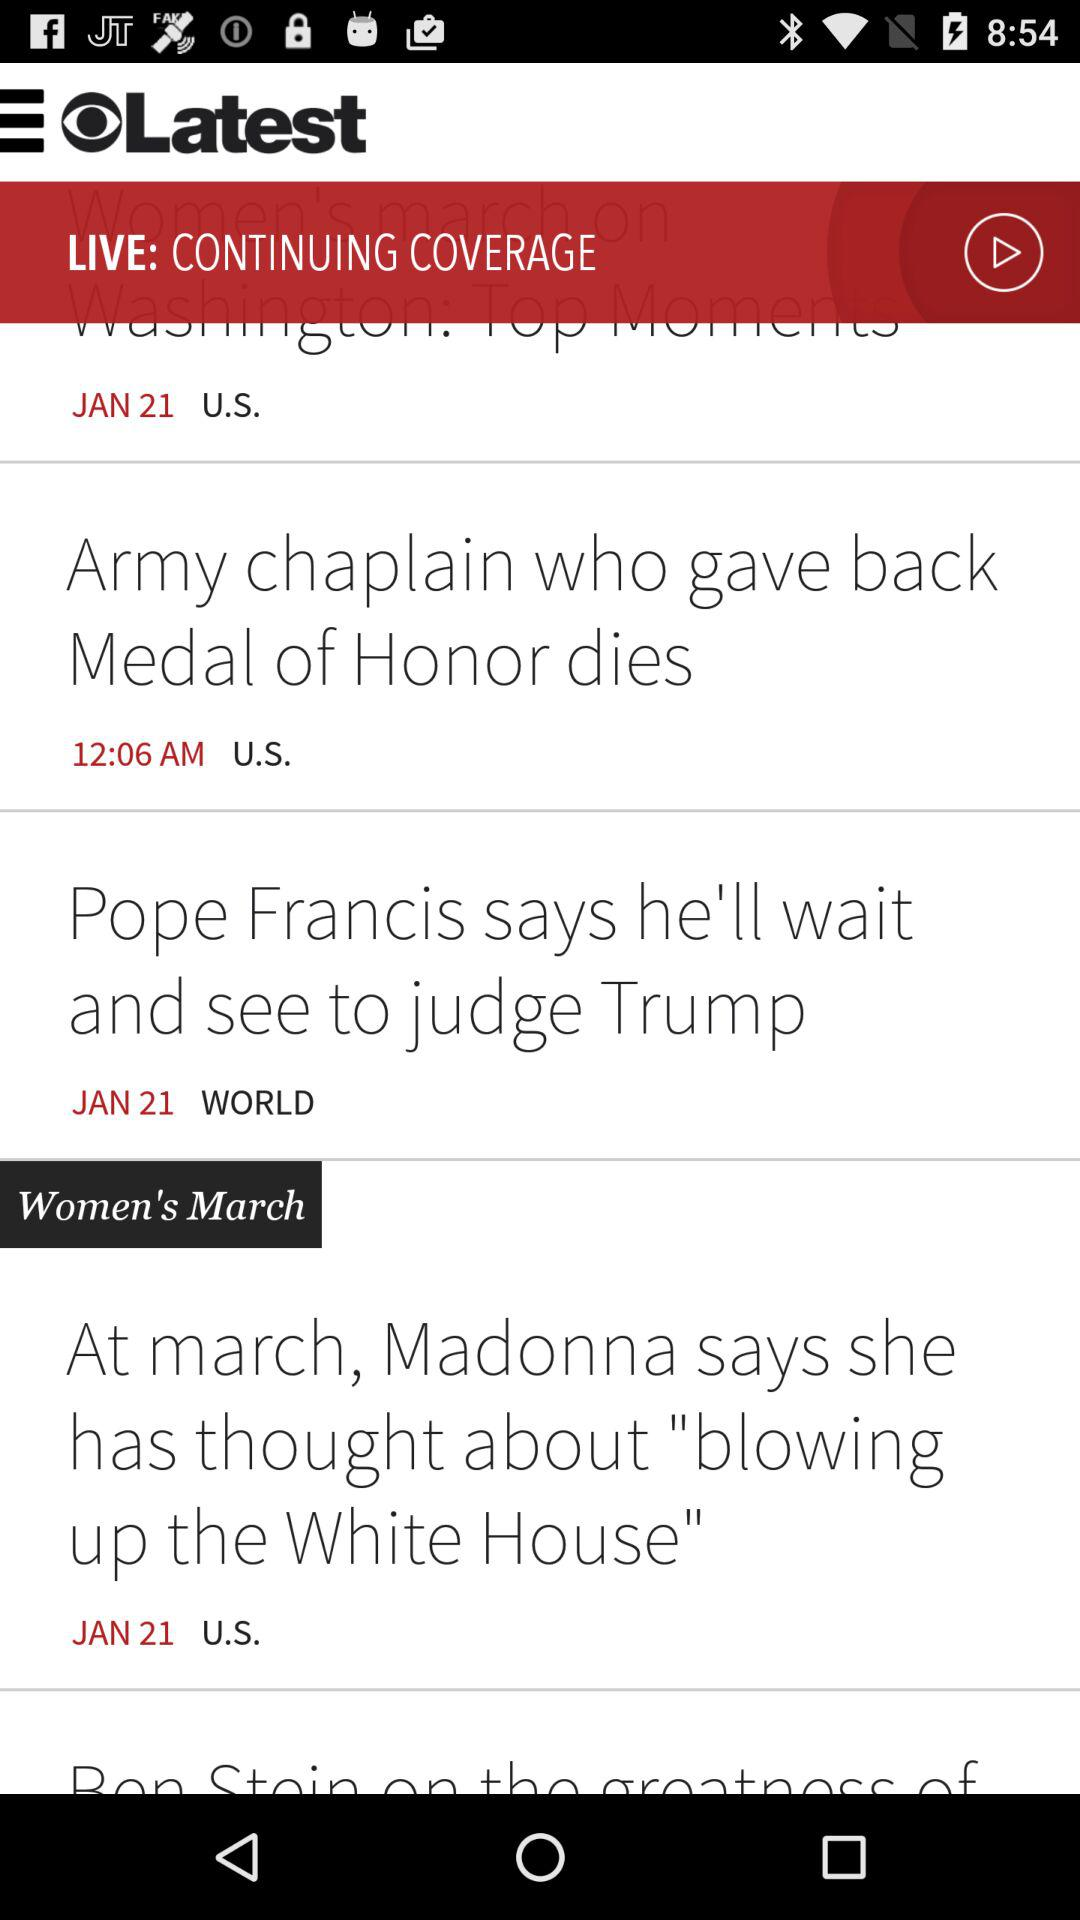What is the country name? The country name is the United States. 